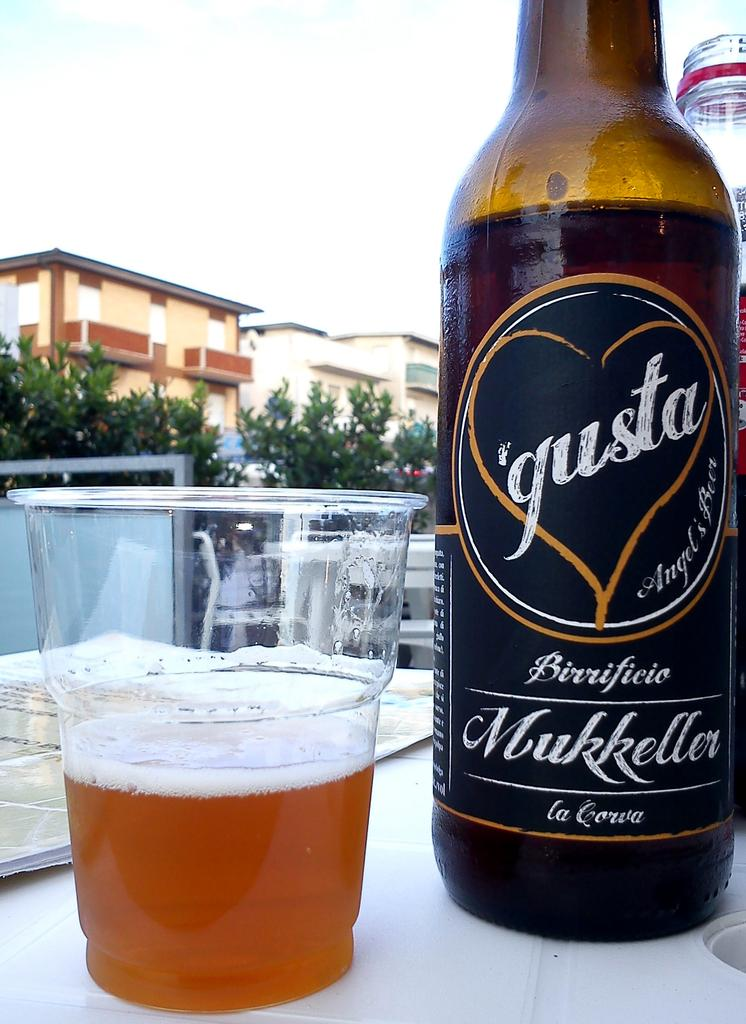<image>
Render a clear and concise summary of the photo. Bottle of Gusta with a heart on it next to a cup of beer. 